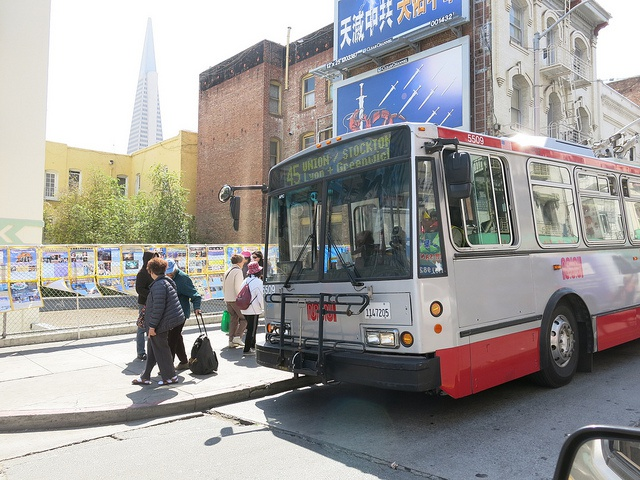Describe the objects in this image and their specific colors. I can see bus in lightgray, darkgray, black, and gray tones, people in lightgray, black, and gray tones, people in lightgray, black, gray, and darkgray tones, people in lightgray, gray, tan, and darkgray tones, and people in lightgray, black, gray, darkblue, and darkgray tones in this image. 